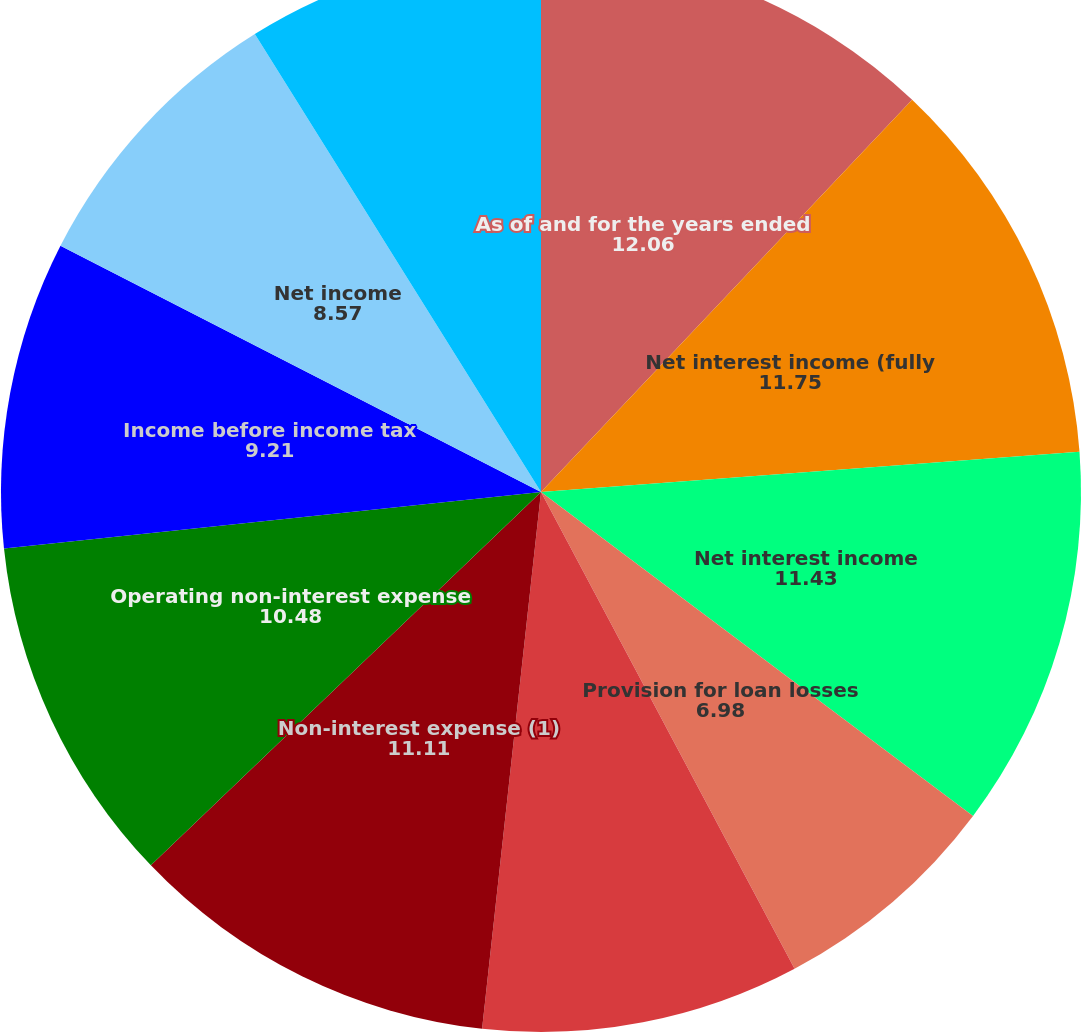Convert chart to OTSL. <chart><loc_0><loc_0><loc_500><loc_500><pie_chart><fcel>As of and for the years ended<fcel>Net interest income (fully<fcel>Net interest income<fcel>Provision for loan losses<fcel>Non-interest income<fcel>Non-interest expense (1)<fcel>Operating non-interest expense<fcel>Income before income tax<fcel>Net income<fcel>Operating earnings (1)<nl><fcel>12.06%<fcel>11.75%<fcel>11.43%<fcel>6.98%<fcel>9.52%<fcel>11.11%<fcel>10.48%<fcel>9.21%<fcel>8.57%<fcel>8.89%<nl></chart> 